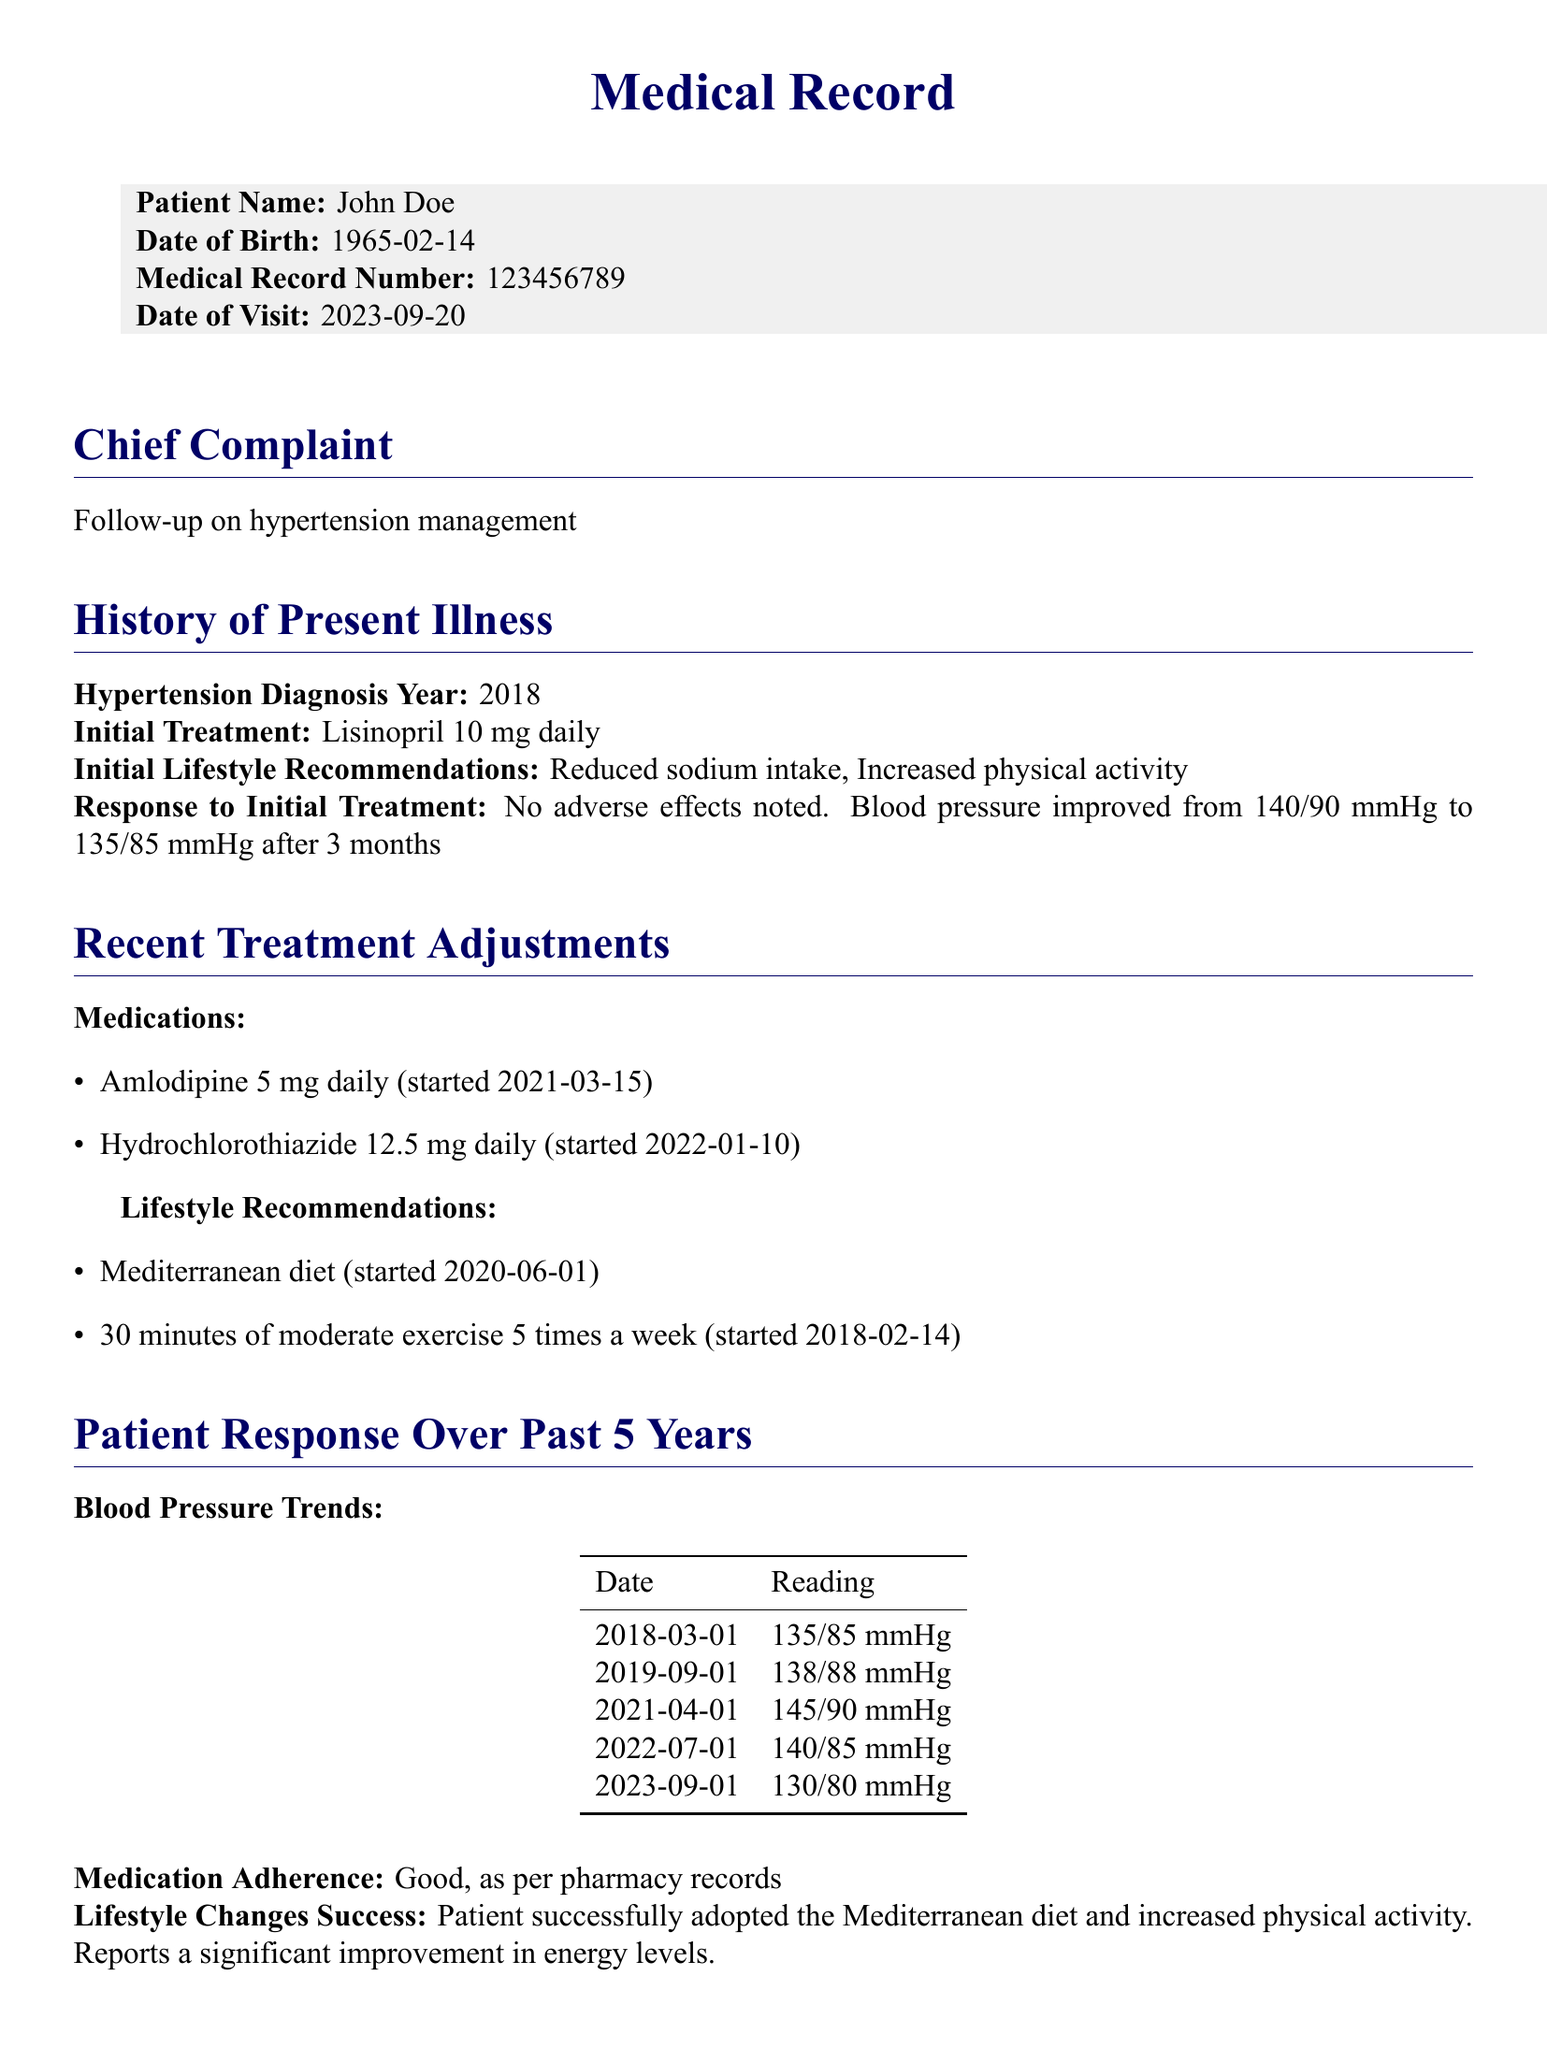What is the patient's name? The patient's name is listed under the patient details section of the document.
Answer: John Doe When was the initial treatment prescribed? The date of the initial treatment can be inferred from the history of present illness section.
Answer: 2018 What medication was started on March 15, 2021? The document lists specific medication adjustments with corresponding start dates.
Answer: Amlodipine 5 mg daily What lifestyle change was recommended starting on June 1, 2020? The lifestyle recommendations section specifies changes along with their start dates.
Answer: Mediterranean diet What is the patient's blood pressure on September 1, 2023? The current status section provides the latest blood pressure reading.
Answer: 130/80 mmHg How many times a week should the patient exercise? The lifestyle recommendations specify the frequency of exercise.
Answer: 5 times a week What was the highest blood pressure reading over the past 5 years? The blood pressure trends table includes multiple readings, allowing for comparison.
Answer: 145/90 mmHg What is the planned next step regarding Amlodipine? The planned next steps section mentions a specific consideration regarding the medication dose.
Answer: Consider possible reduction in Amlodipine dose if blood pressure remains stable 